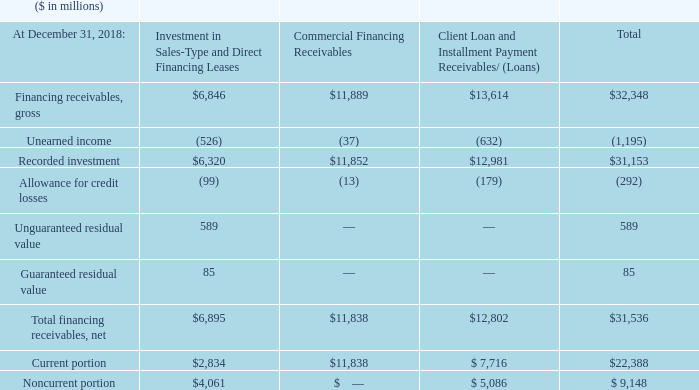The company utilizes certain of its financing receivables as collateral for nonrecourse borrowings. Financing receivables pledged as collateral for borrowings were $1,062 million and $710 million at December 31, 2019 and 2018, respectively. These borrowings are included in note P, “Borrowings.”
The company did not have any financing receivables held for sale as of December 31, 2019 and 2018.
How does the company utilizes certain of its financing receivables? The company utilizes certain of its financing receivables as collateral for nonrecourse borrowings. What amount of Financing receivables pledged as collateral for borrowings in December 2018 and 2019? Financing receivables pledged as collateral for borrowings were $1,062 million and $710 million at december 31, 2019 and 2018, respectively. Did the company have any financing receivables held for sale as of December 2019 and 2018. The company did not have any financing receivables held for sale as of december 31, 2019 and 2018. What is the average Unearned income?
Answer scale should be: million. 1,195 / 3
Answer: 398.33. What is the average Recorded investment?
Answer scale should be: million. 31,153 / 3
Answer: 10384.33. How much is the difference between Unguaranteed and Guaranteed residual value of Investment in Sales-Type and Direct Financing Leases?
Answer scale should be: million. 589-85 
Answer: 504. 